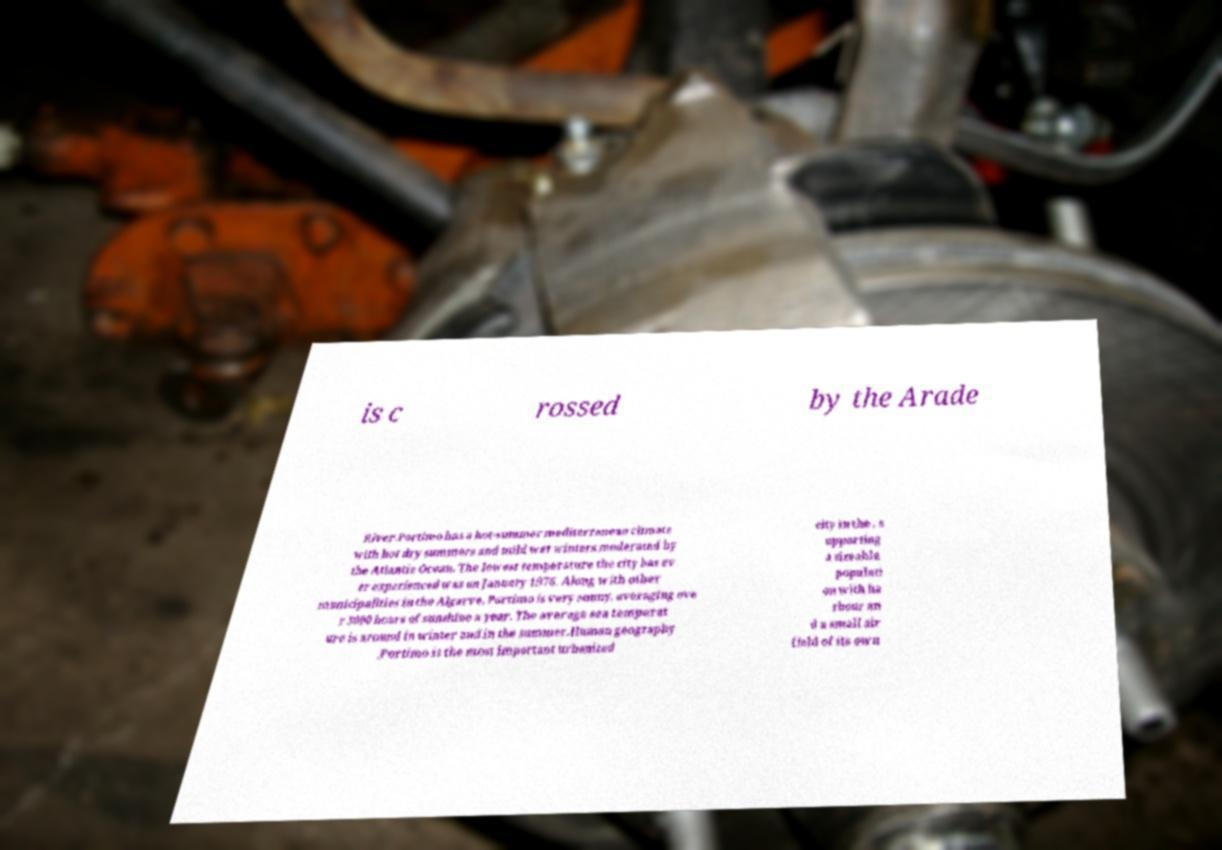What messages or text are displayed in this image? I need them in a readable, typed format. is c rossed by the Arade River.Portimo has a hot-summer mediterranean climate with hot dry summers and mild wet winters moderated by the Atlantic Ocean. The lowest temperature the city has ev er experienced was on January 1976. Along with other municipalities in the Algarve, Portimo is very sunny, averaging ove r 3000 hours of sunshine a year. The average sea temperat ure is around in winter and in the summer.Human geography .Portimo is the most important urbanized city in the , s upporting a sizeable populati on with ha rbour an d a small air field of its own 